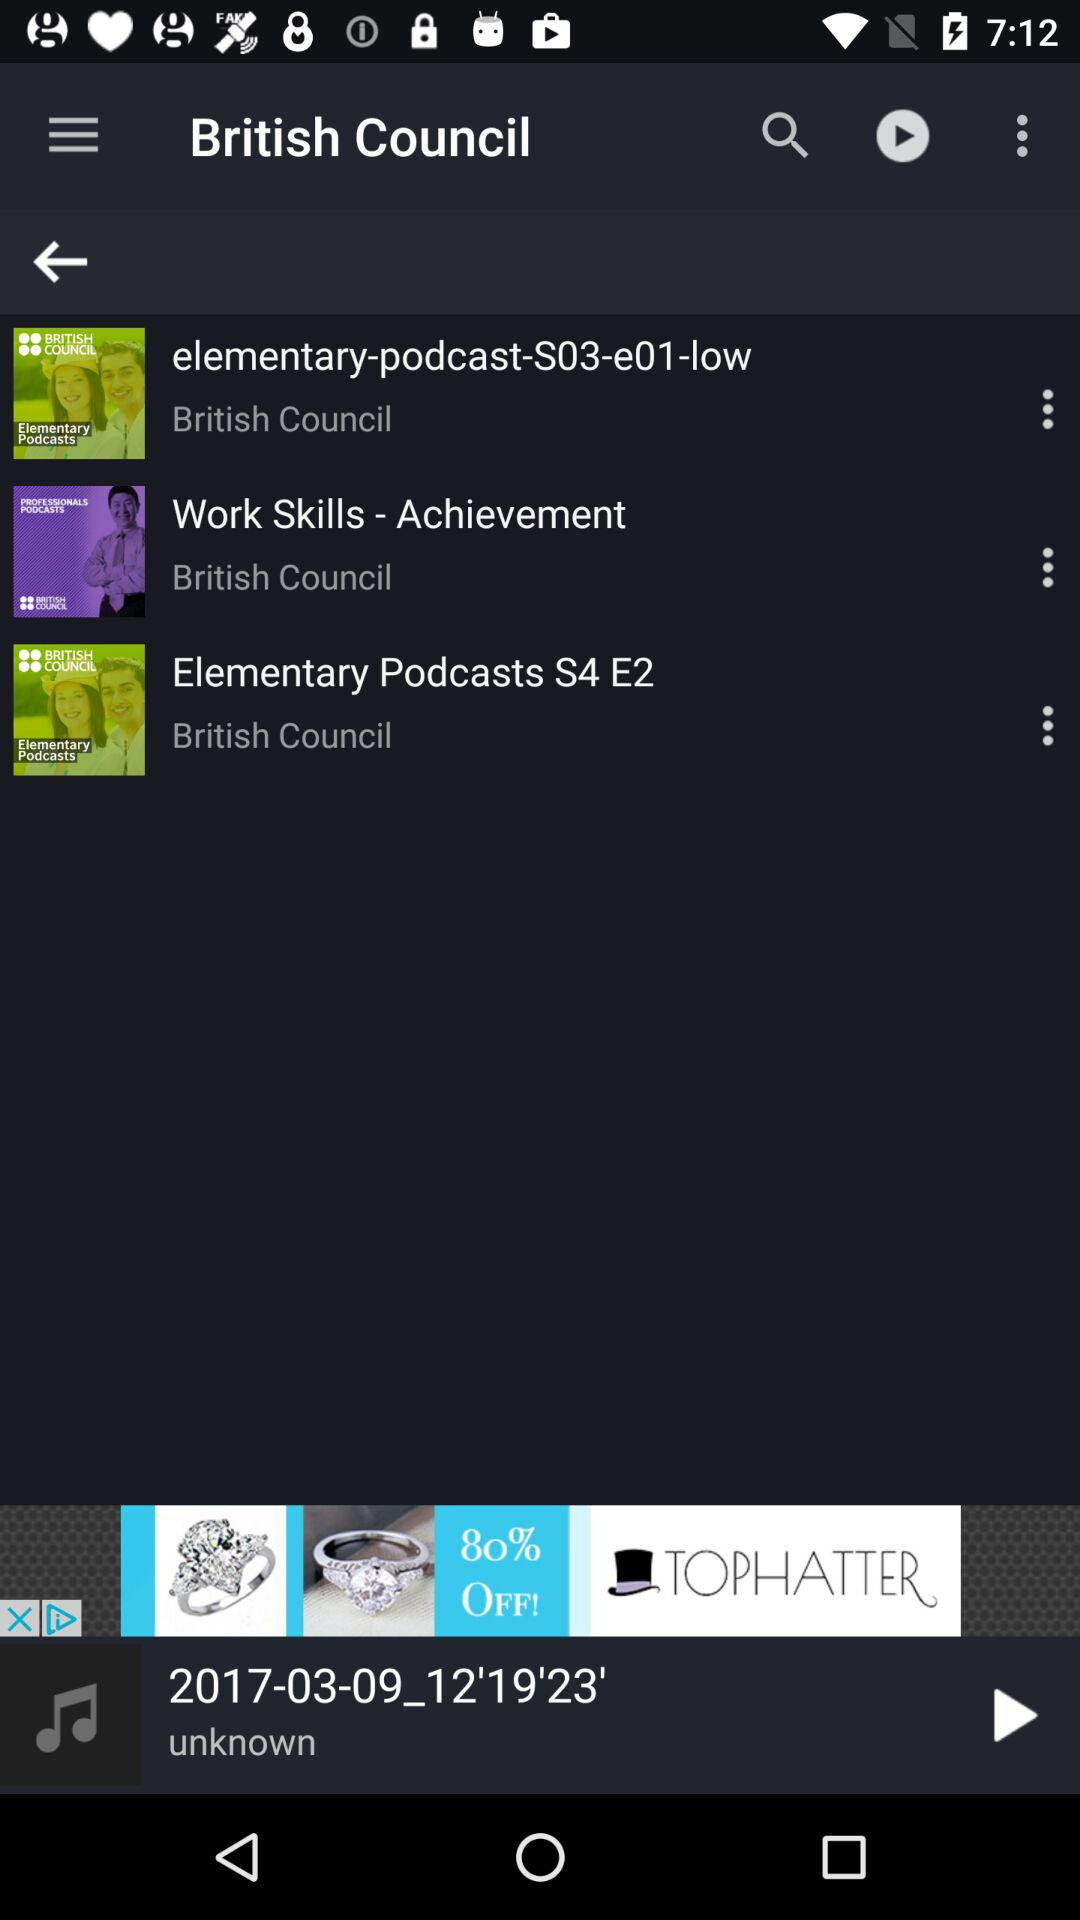How many items have the text 'British Council'?
Answer the question using a single word or phrase. 3 